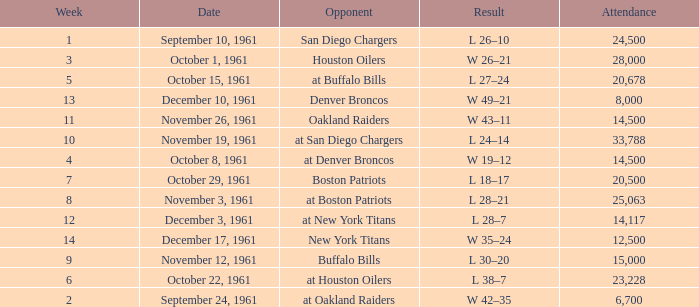What is the top attendance for weeks past 2 on october 29, 1961? 20500.0. 